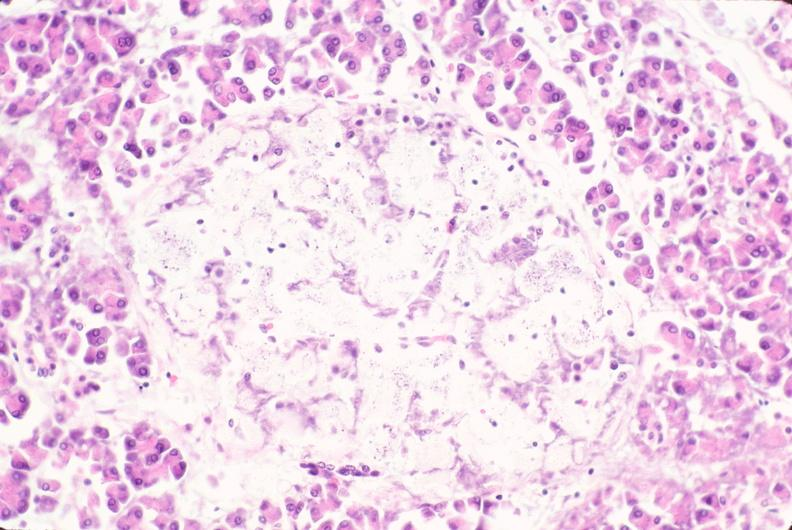s endocrine present?
Answer the question using a single word or phrase. Yes 